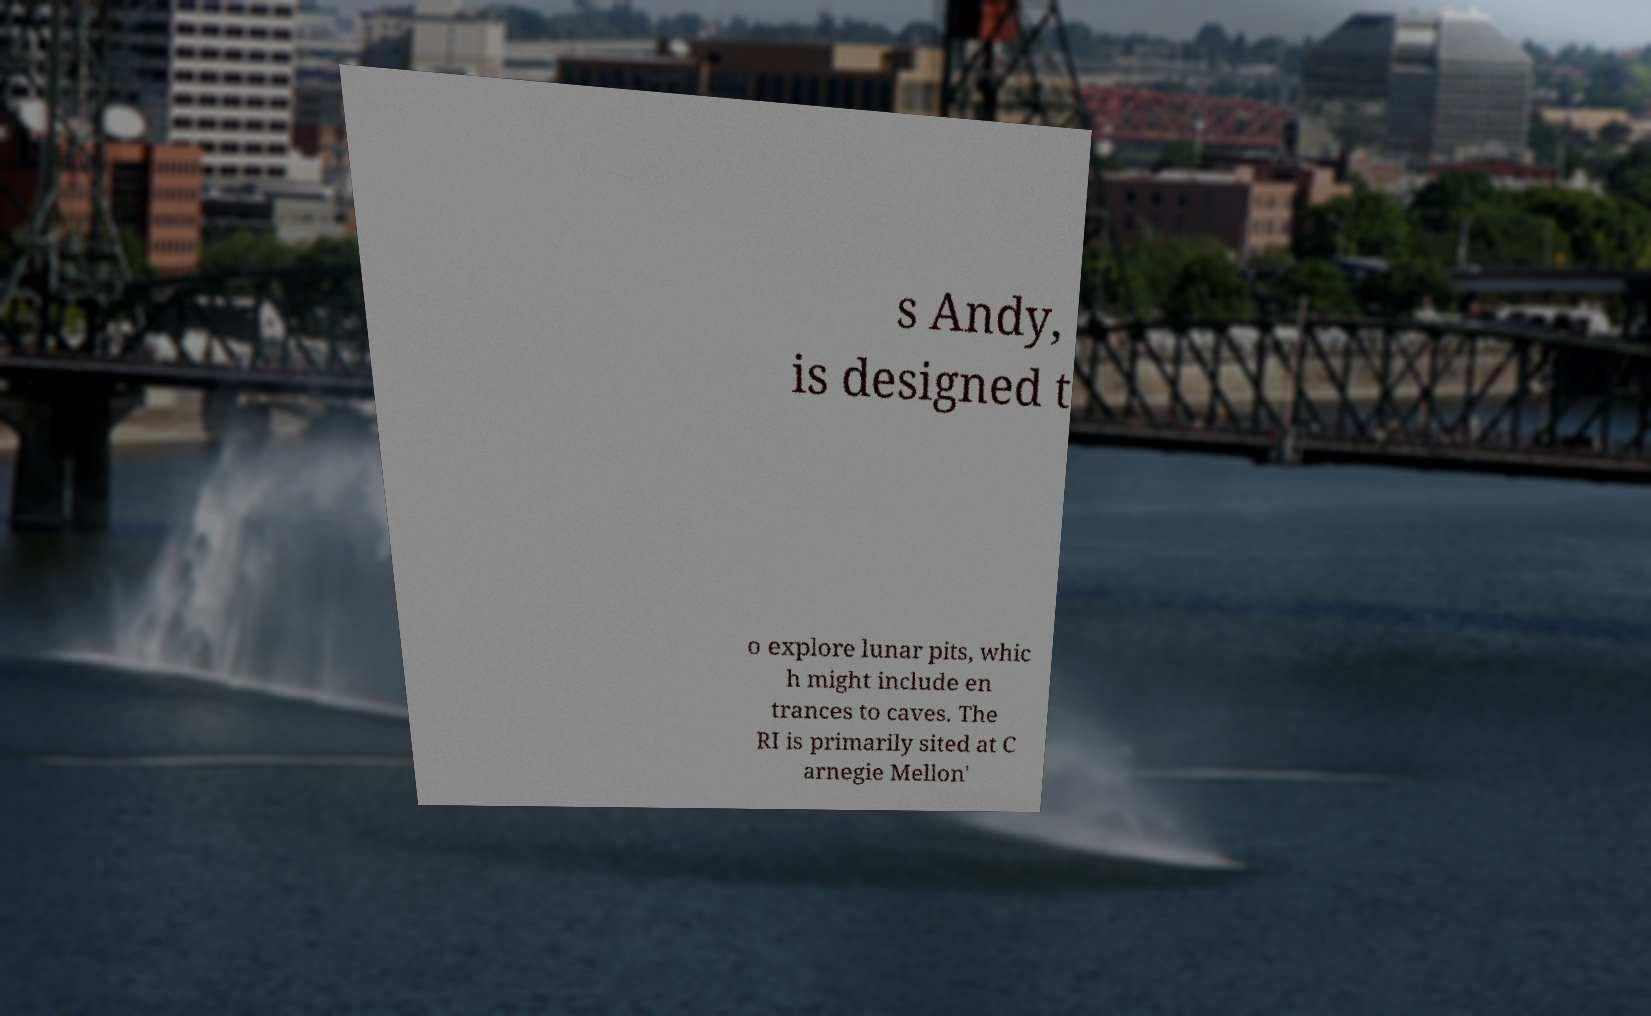Please read and relay the text visible in this image. What does it say? s Andy, is designed t o explore lunar pits, whic h might include en trances to caves. The RI is primarily sited at C arnegie Mellon' 